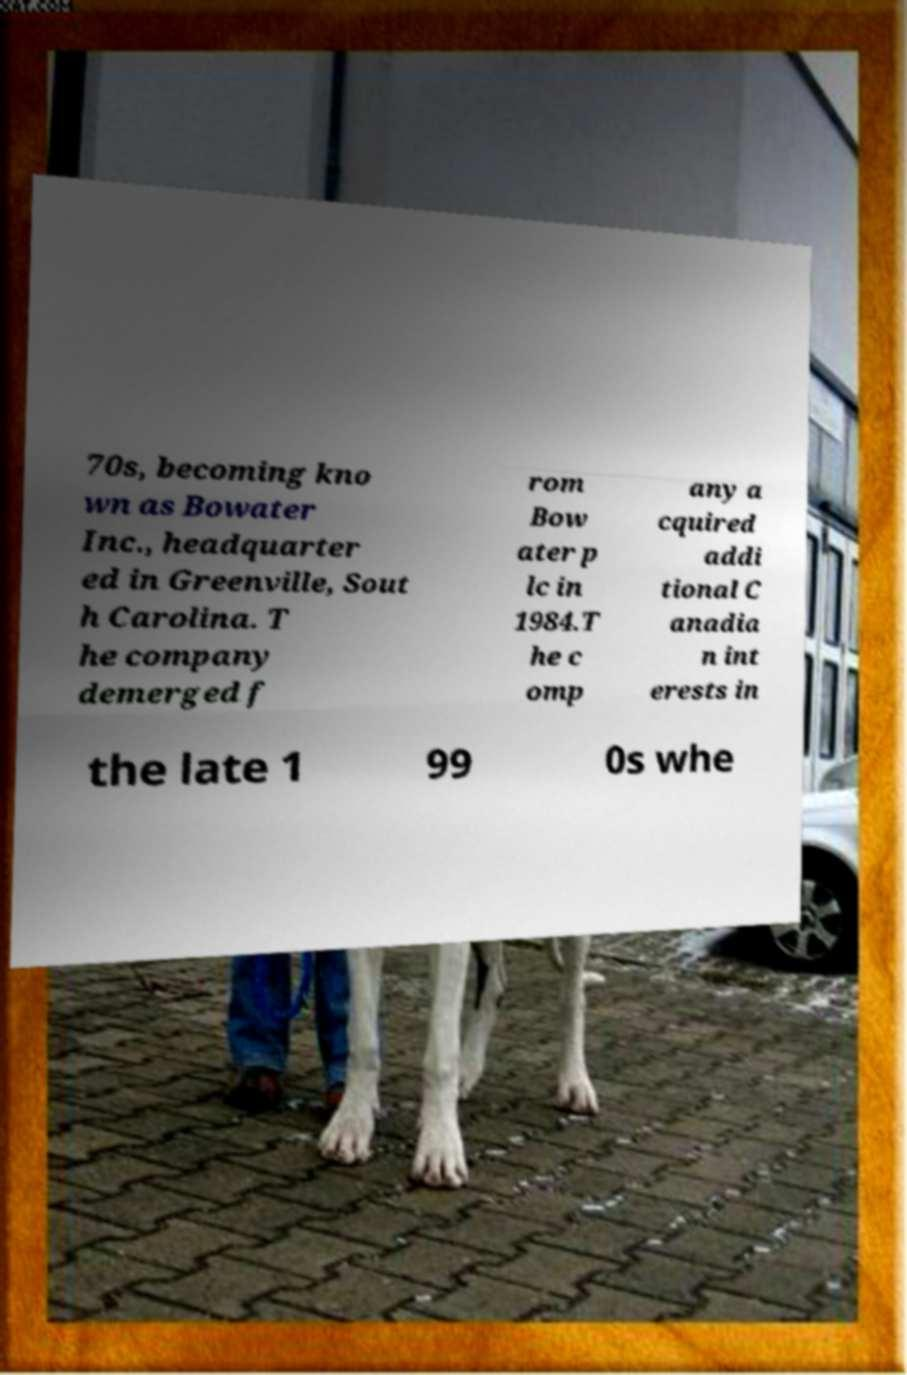Please read and relay the text visible in this image. What does it say? 70s, becoming kno wn as Bowater Inc., headquarter ed in Greenville, Sout h Carolina. T he company demerged f rom Bow ater p lc in 1984.T he c omp any a cquired addi tional C anadia n int erests in the late 1 99 0s whe 